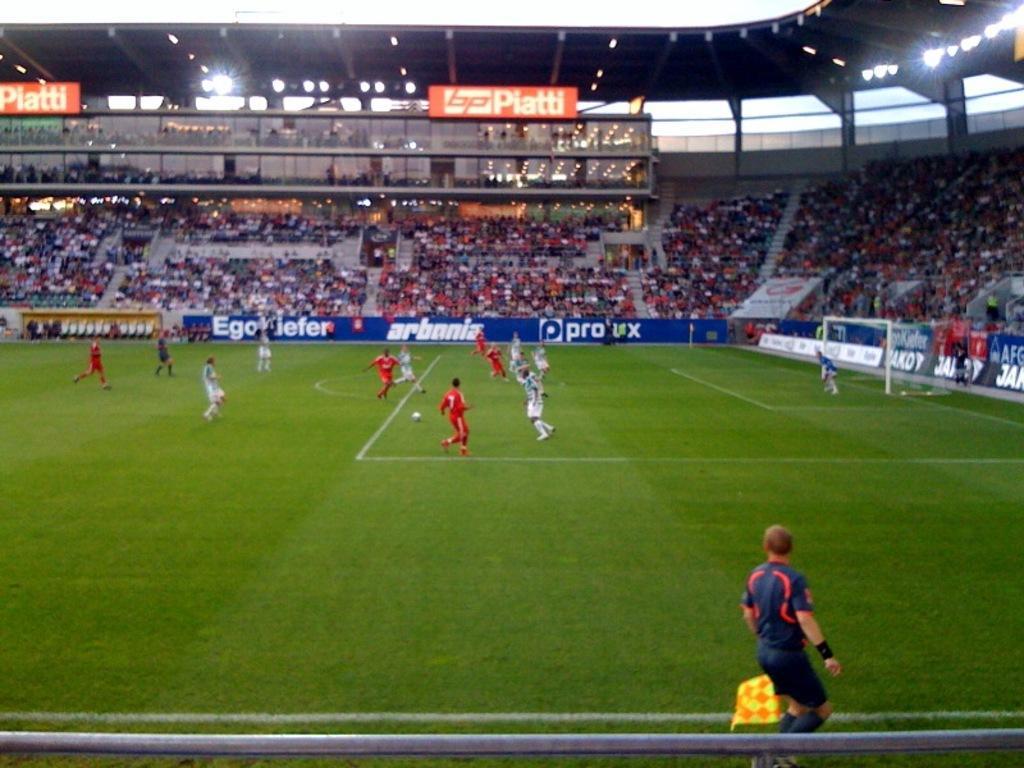Describe this image in one or two sentences. In the foreground I can see a group of people are playing a football on the ground, goal net and a fence. In the background I can see a crowd in the stadium. On the top I can see lights, boards. This image is taken in a stadium. 